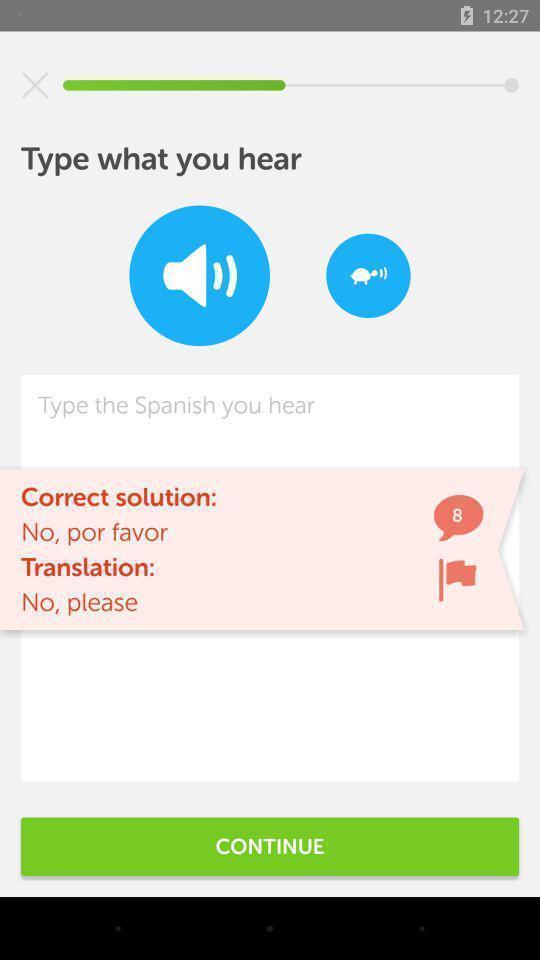Tell me what you see in this picture. Screen page of language translator application. 